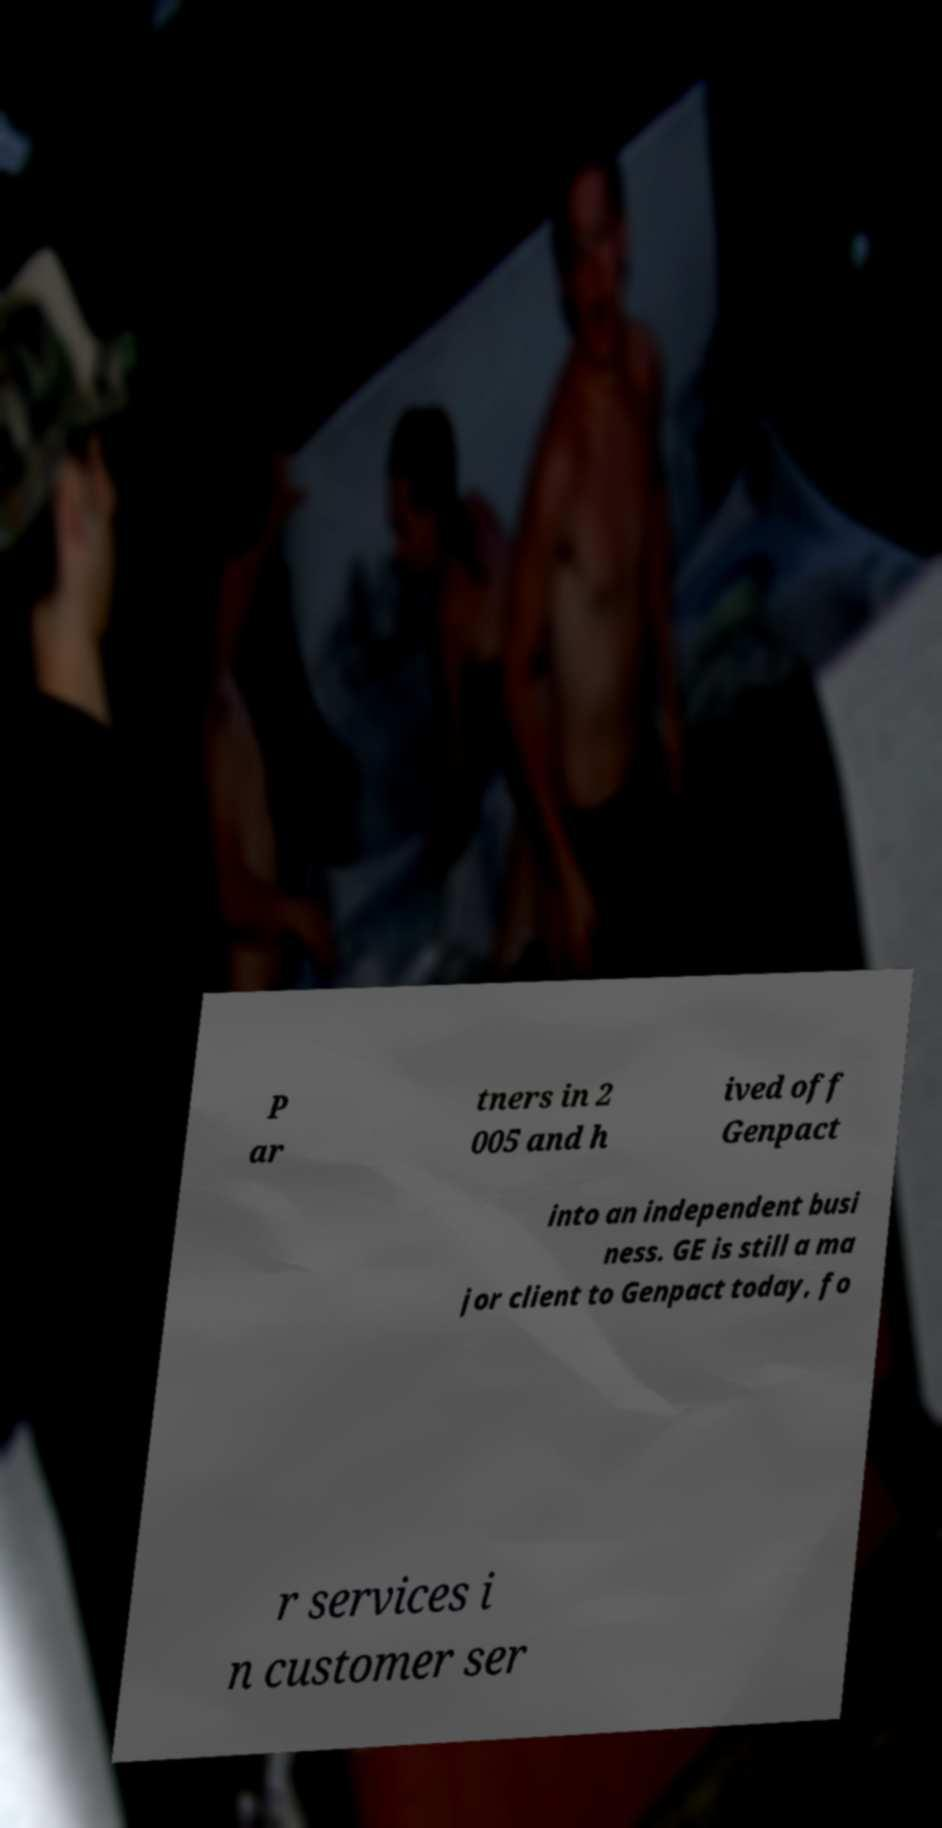Can you read and provide the text displayed in the image?This photo seems to have some interesting text. Can you extract and type it out for me? P ar tners in 2 005 and h ived off Genpact into an independent busi ness. GE is still a ma jor client to Genpact today, fo r services i n customer ser 